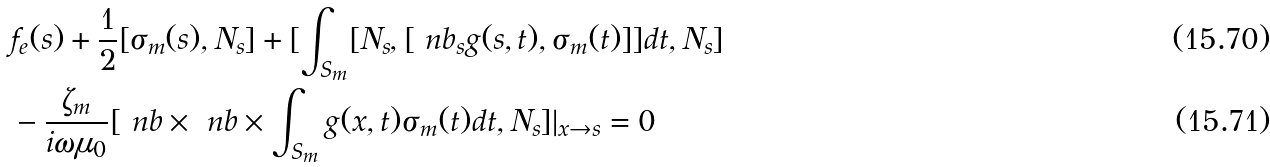Convert formula to latex. <formula><loc_0><loc_0><loc_500><loc_500>& f _ { e } ( s ) + \frac { 1 } { 2 } [ \sigma _ { m } ( s ) , N _ { s } ] + [ \int _ { S _ { m } } [ N _ { s } , [ \ n b _ { s } g ( s , t ) , \sigma _ { m } ( t ) ] ] d t , N _ { s } ] \\ & - \frac { \zeta _ { m } } { i \omega \mu _ { 0 } } [ \ n b \times \ n b \times \int _ { S _ { m } } g ( x , t ) \sigma _ { m } ( t ) d t , N _ { s } ] | _ { x \to s } = 0</formula> 